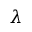Convert formula to latex. <formula><loc_0><loc_0><loc_500><loc_500>\lambda</formula> 